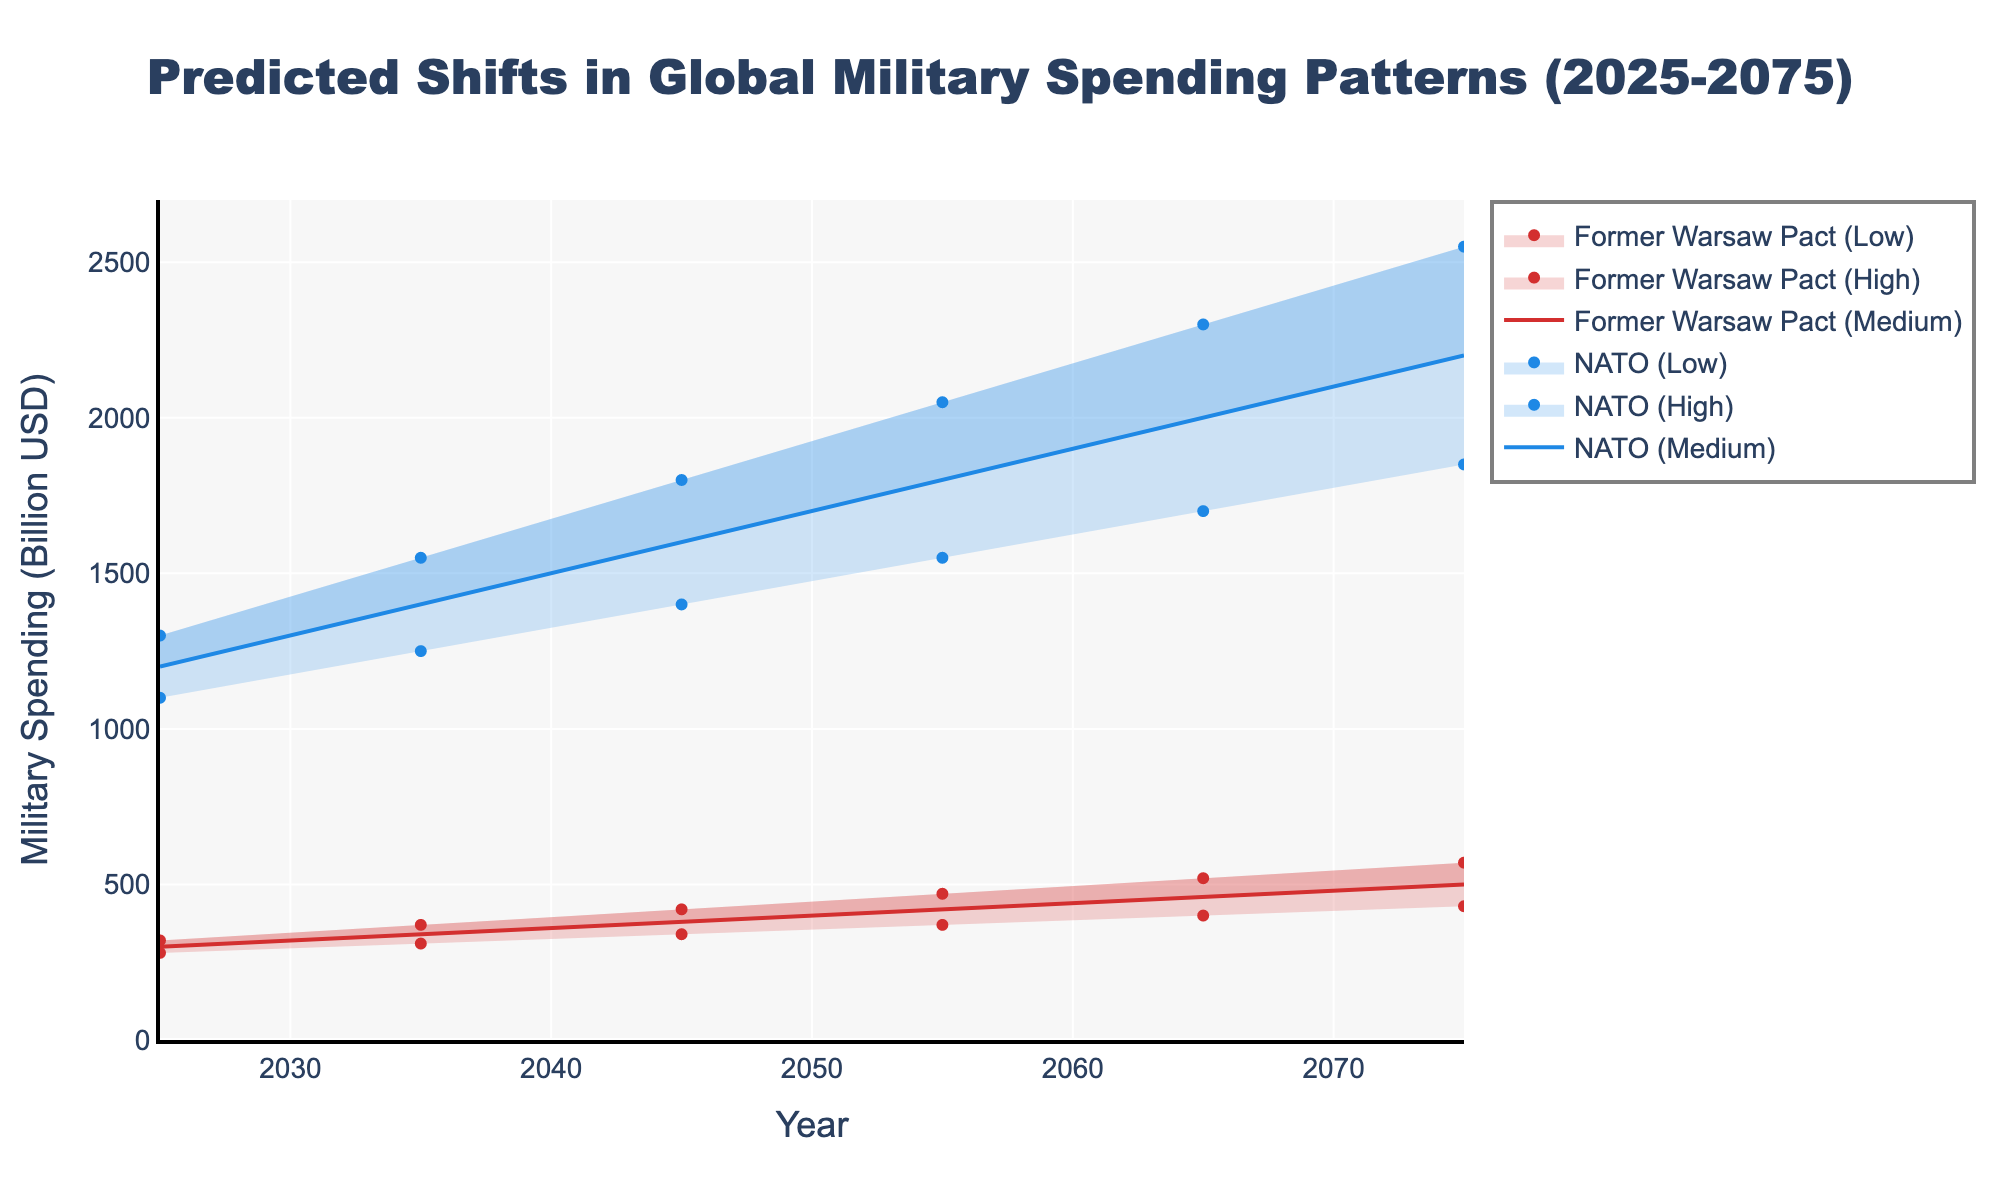What is the title of the plot? The title is typically displayed at the top of the figure and summarizes what the plot is depicting. Here, the title reads "Predicted Shifts in Global Military Spending Patterns (2025-2075)".
Answer: Predicted Shifts in Global Military Spending Patterns (2025-2075) What are the colors used to represent NATO and Former Warsaw Pact countries? The plot uses blue color for NATO data points and red color for Former Warsaw Pact countries. The medium projections are solid lines, while light shades are used for the high and low predictions.
Answer: Blue for NATO, Red for Former Warsaw Pact What is the projected medium military spending for NATO in 2075? The medium projection data for NATO in 2075 is found by looking at the blue solid line labeled 'NATO (Medium)' and its corresponding y-axis value. The value is 2200 billion USD.
Answer: 2200 billion USD By how much is the medium spending for NATO expected to increase from 2025 to 2075? In 2025, the medium spending value for NATO is 1200 billion USD. In 2075, it is 2200 billion USD. The increase is calculated by subtracting 1200 from 2200.
Answer: (2200 - 1200) billion USD = 1000 billion USD Compare the range of military spending projections for Former Warsaw Pact countries in 2045. The low and high projections for Former Warsaw Pact countries in 2045 are 340 billion USD and 420 billion USD respectively. The range is the difference between high and low values.
Answer: (420 - 340) billion USD = 80 billion USD How does the growth in medium military spending for Former Warsaw Pact countries from 2035 to 2055 compare to the growth from 2055 to 2075? The medium spending in 2035 is 340 billion USD and in 2055 is 420 billion USD, giving a growth of 80 billion USD. From 2055 to 2075, it grows from 420 to 500 billion USD, giving a growth of 80 billion USD again.
Answer: 80 billion USD (both periods) Which year shows the smallest predicted gap between high and low NATO spending projections? To find the year with the smallest gap between high and low spending projections for NATO, calculate the difference for each year. In 2025 the gap is (1300-1100=200), in 2035 it is (1550-1250=300), in 2045 it is (1800-1400=400), in 2055 it is (2050-1550=500), in 2065 it is (2300-1700=600), and in 2075 it is (2550-1850=700). The smallest gap is in 2025.
Answer: 2025 What is the average projected medium spending for NATO over all the years? Add the medium spending values for NATO: 1200, 1400, 1600, 1800, 2000, and 2200 billion USD, and divide the sum by the number of years (6). (1200+1400+1600+1800+2000+2200)/6 = 1700 billion USD.
Answer: 1700 billion USD 